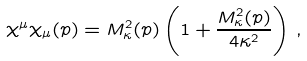<formula> <loc_0><loc_0><loc_500><loc_500>\chi ^ { \mu } \chi _ { \mu } ( p ) = M ^ { 2 } _ { \kappa } ( p ) \left ( 1 + \frac { M ^ { 2 } _ { \kappa } ( p ) } { 4 \kappa ^ { 2 } } \right ) \, ,</formula> 